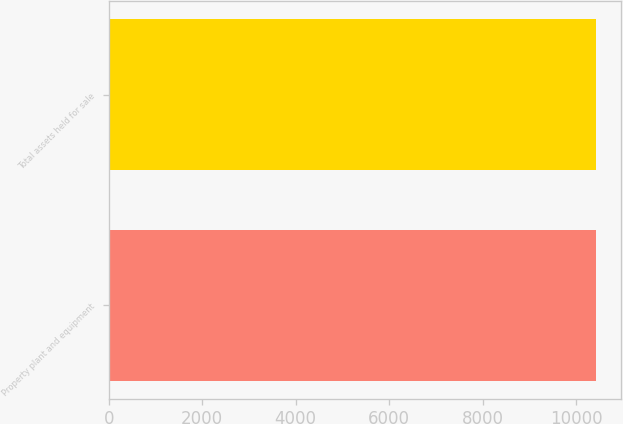Convert chart. <chart><loc_0><loc_0><loc_500><loc_500><bar_chart><fcel>Property plant and equipment<fcel>Total assets held for sale<nl><fcel>10428<fcel>10428.1<nl></chart> 